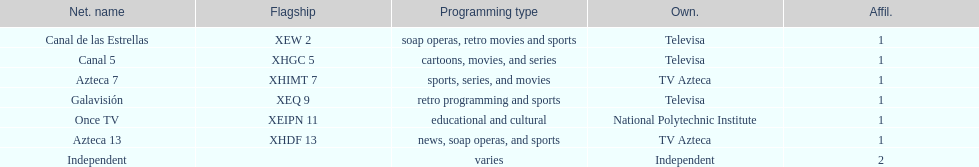What is the total number of affiliates among all the networks? 8. 